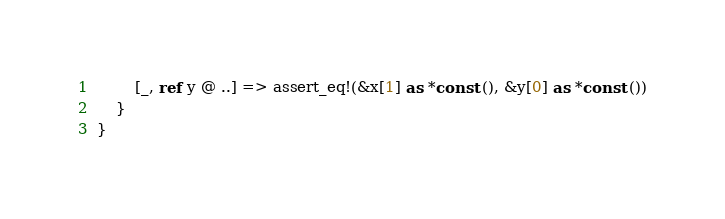<code> <loc_0><loc_0><loc_500><loc_500><_Rust_>        [_, ref y @ ..] => assert_eq!(&x[1] as *const (), &y[0] as *const ())
    }
}
</code> 